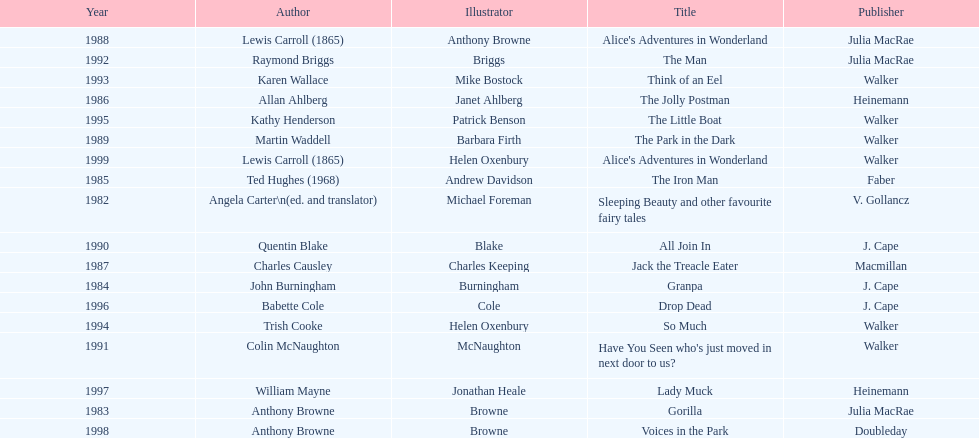Which other author, besides lewis carroll, has won the kurt maschler award twice? Anthony Browne. 